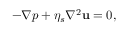Convert formula to latex. <formula><loc_0><loc_0><loc_500><loc_500>- \nabla p + \eta _ { s } \nabla ^ { 2 } { u } = 0 ,</formula> 